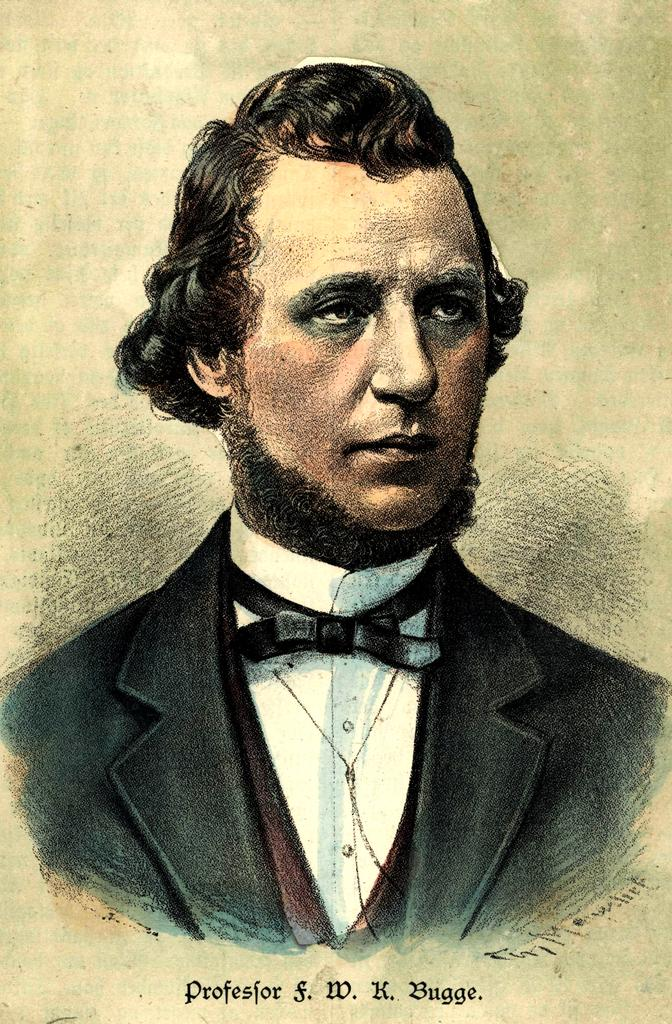What is depicted in the painting in the image? There is a painting of a man in the image. Are there any additional features visible in the image besides the painting? Yes, there is a watermark visible in the image. What type of guide is the man holding in the painting? The painting does not show the man holding a guide; it only depicts the man himself. 